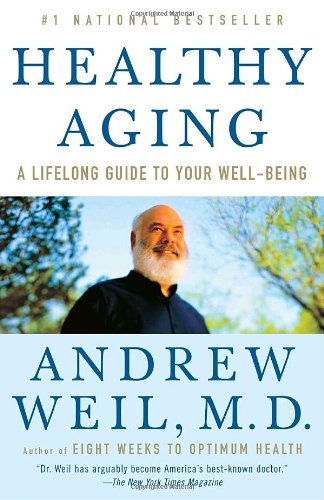Who wrote this book?
Answer the question using a single word or phrase. Andrew Weil M.D. What is the title of this book? Healthy Aging: A Lifelong Guide to Your Well-Being What is the genre of this book? Health, Fitness & Dieting Is this a fitness book? Yes Is this a homosexuality book? No 